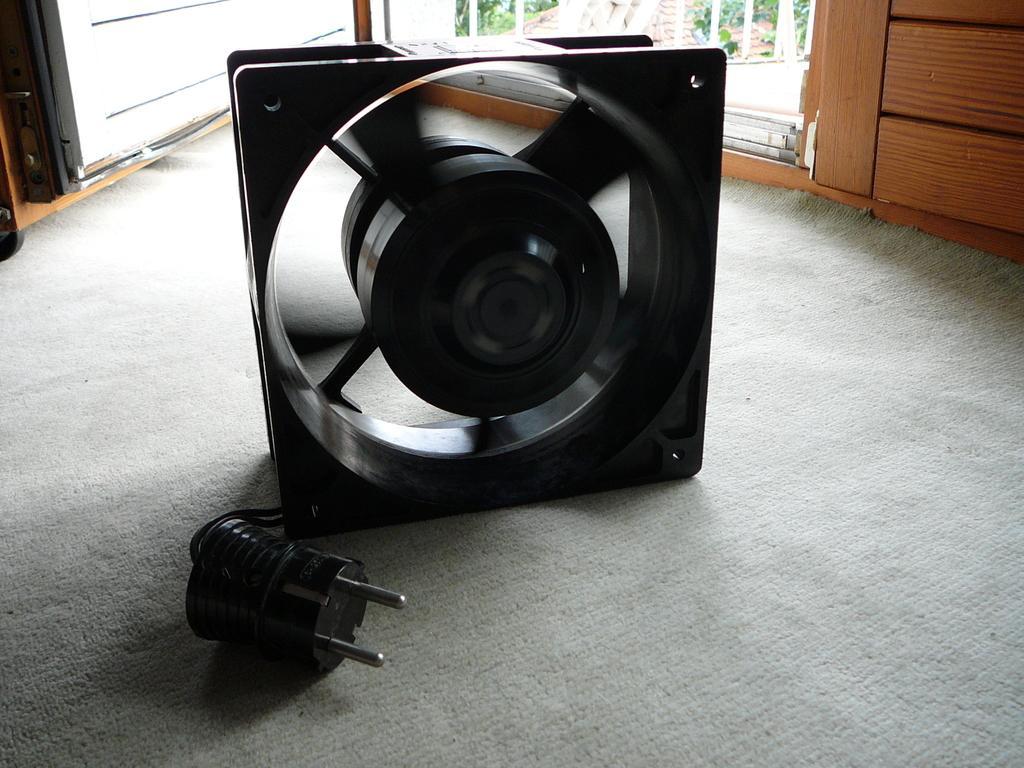Describe this image in one or two sentences. In the picture we can see a fan, which is black in color with a switch and behind it, we can see a wooden door which is opened. 